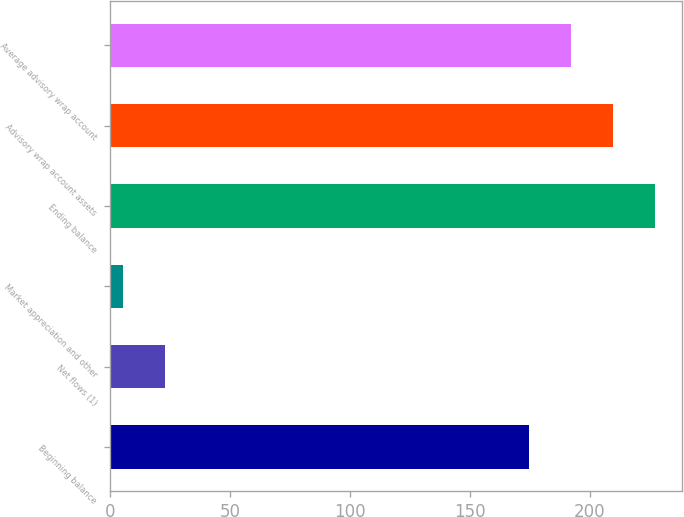Convert chart to OTSL. <chart><loc_0><loc_0><loc_500><loc_500><bar_chart><fcel>Beginning balance<fcel>Net flows (1)<fcel>Market appreciation and other<fcel>Ending balance<fcel>Advisory wrap account assets<fcel>Average advisory wrap account<nl><fcel>174.7<fcel>22.82<fcel>5.3<fcel>227.26<fcel>209.74<fcel>192.22<nl></chart> 